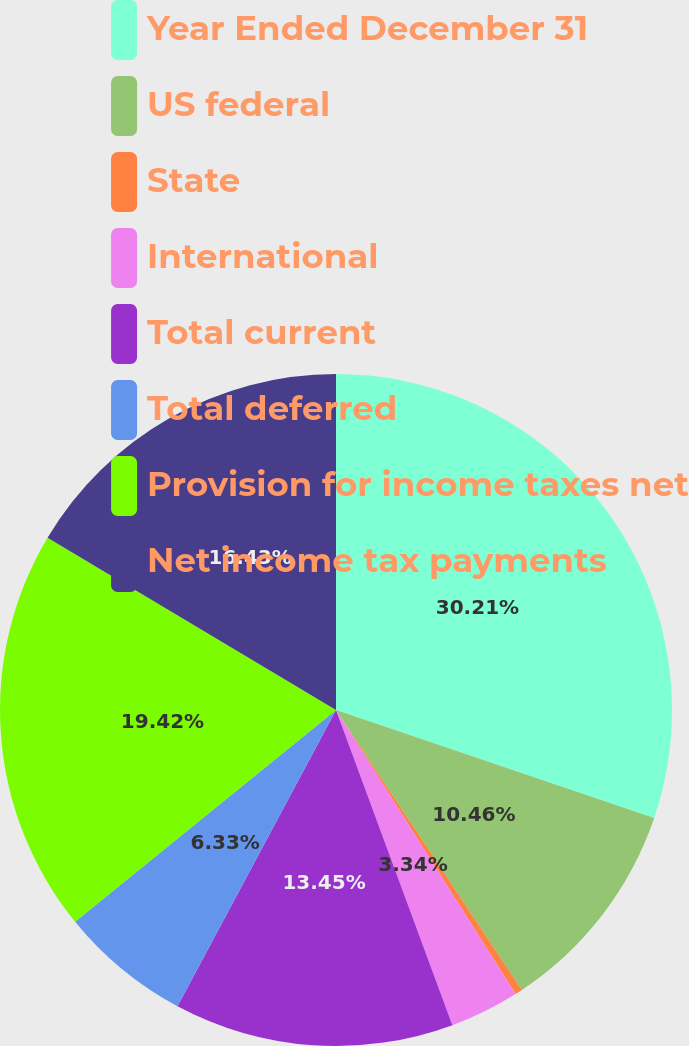Convert chart to OTSL. <chart><loc_0><loc_0><loc_500><loc_500><pie_chart><fcel>Year Ended December 31<fcel>US federal<fcel>State<fcel>International<fcel>Total current<fcel>Total deferred<fcel>Provision for income taxes net<fcel>Net income tax payments<nl><fcel>30.21%<fcel>10.46%<fcel>0.36%<fcel>3.34%<fcel>13.45%<fcel>6.33%<fcel>19.42%<fcel>16.43%<nl></chart> 